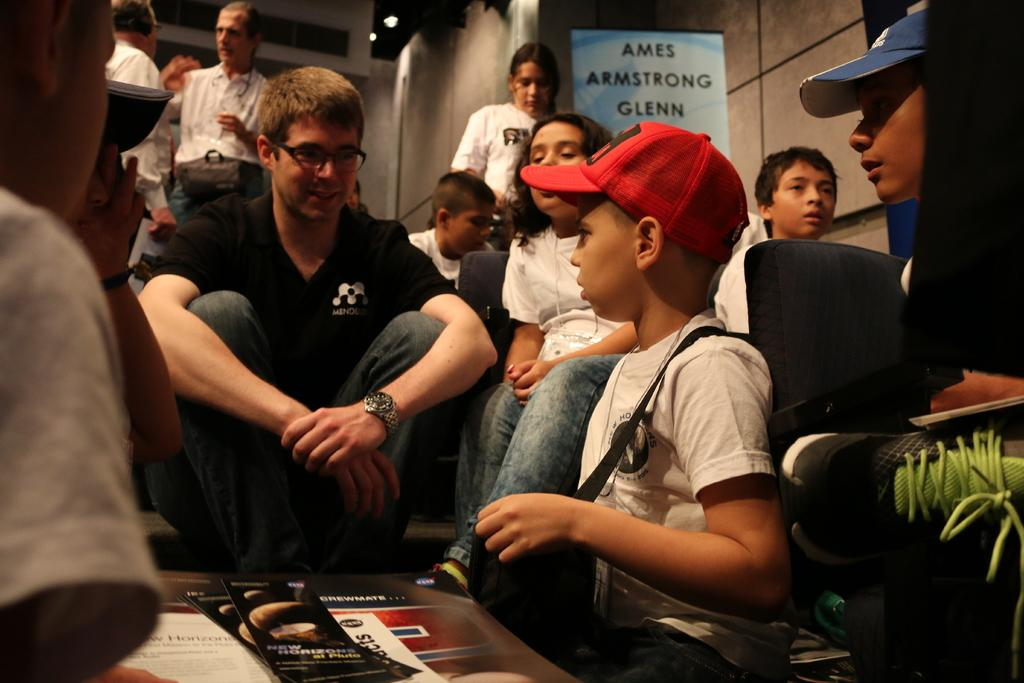Who is present in the image? There are persons and kids in the image. What are the persons and kids wearing? They are wearing clothes. What can be seen at the top of the image? There is a banner at the top of the image. What is the income of the cloth used in the image? There is no cloth or income mentioned in the image; it features persons, kids, and a banner. 